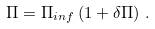<formula> <loc_0><loc_0><loc_500><loc_500>\Pi = \Pi _ { i n f } \left ( 1 + \delta \Pi \right ) \, .</formula> 